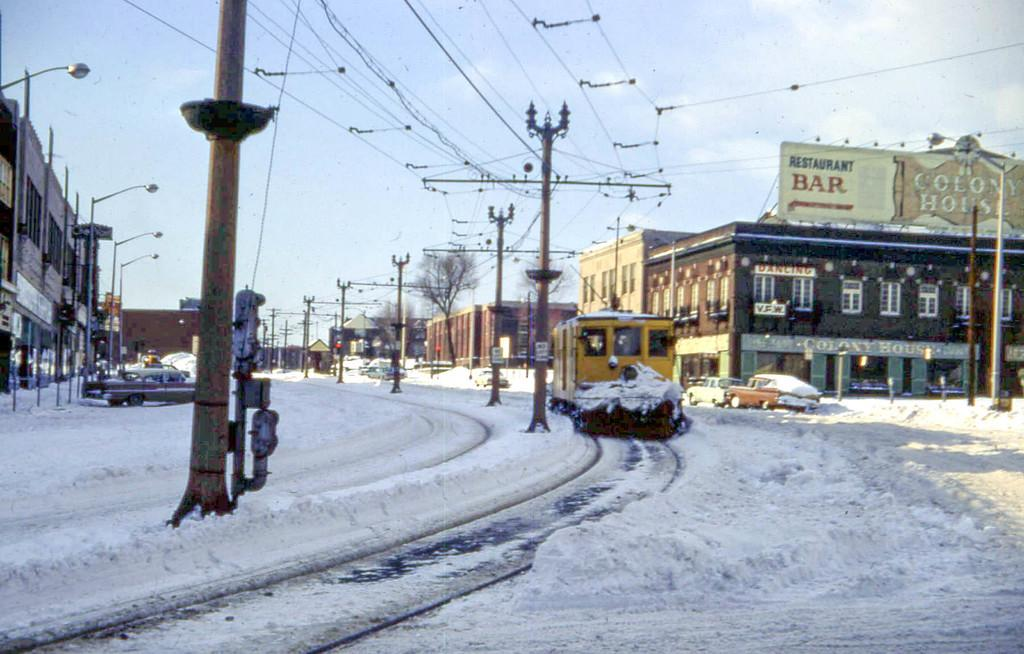<image>
Share a concise interpretation of the image provided. A bar sign on top of a building is visible from the snowy street. 